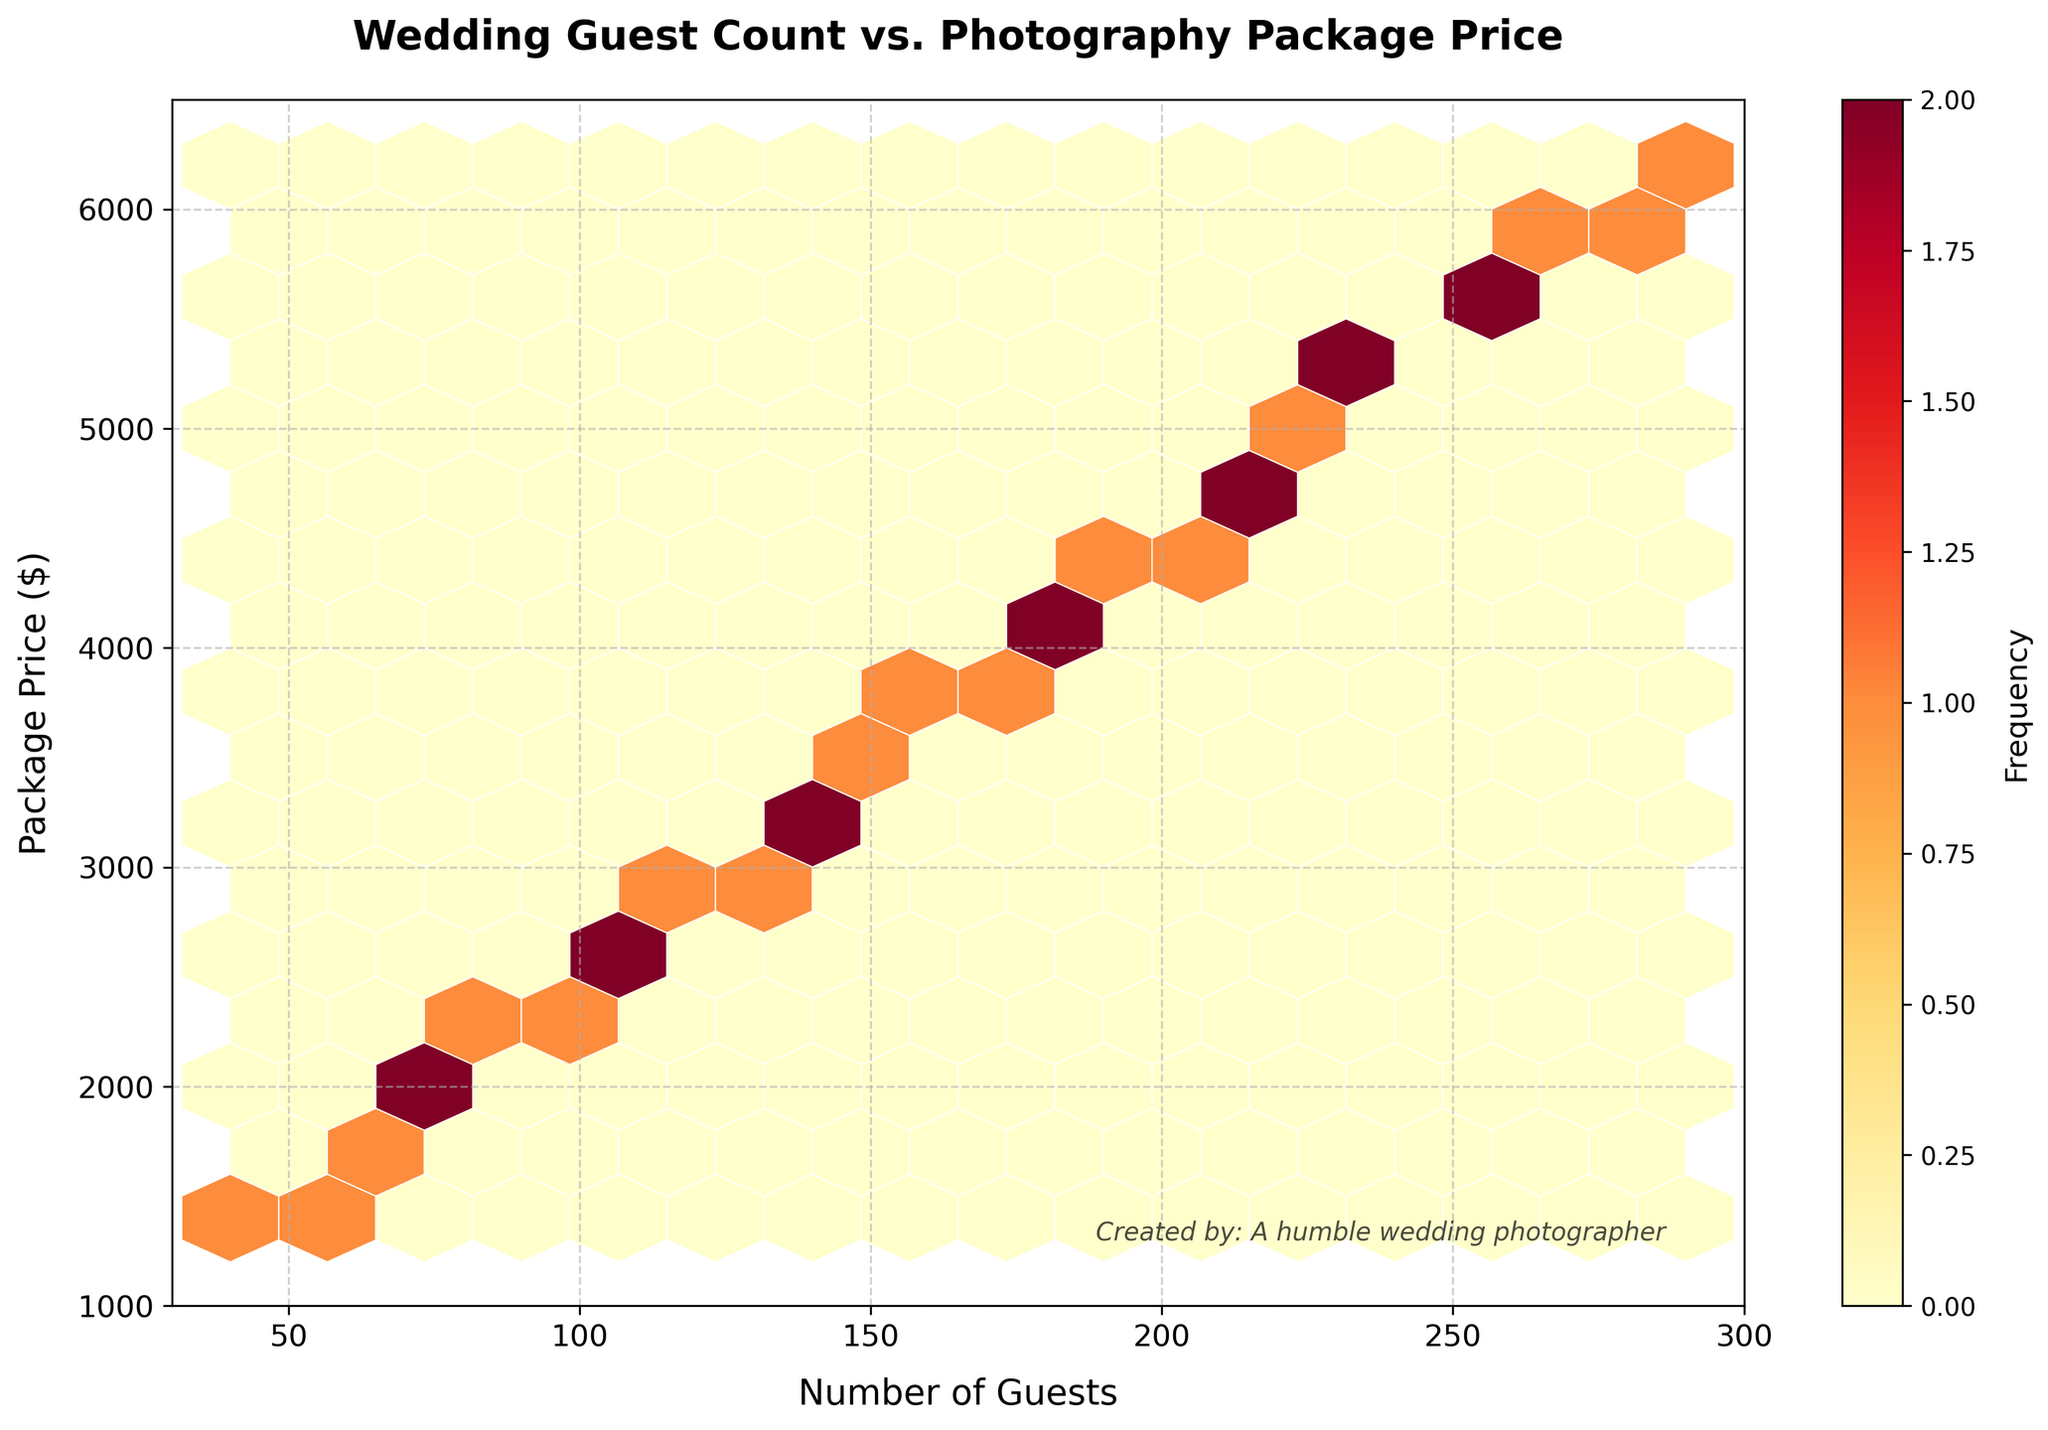What is the title of the plot? The title of the plot is displayed at the top center and reads "Wedding Guest Count vs. Photography Package Price".
Answer: Wedding Guest Count vs. Photography Package Price What are the labels of the x-axis and y-axis? The x-axis label is found below the horizontal axis and reads 'Number of Guests'. The y-axis label is found beside the vertical axis and reads 'Package Price ($)'.
Answer: Number of Guests and Package Price ($) What is the color of the hexagons representing the highest frequency? The hexagons with the highest frequency are shown in a darker shade of red.
Answer: Dark red What is the range of values on the x-axis? The x-axis is labeled 'Number of Guests' and ranges from 30 to 300, as shown below the axis.
Answer: 30 to 300 What is the color representing the lowest frequency in the hexbin plot? The color representing the lowest frequency in the hexbin plot is a light yellow, indicating fewer data points in those regions.
Answer: Light yellow What is the general trend shown in the hexbin plot? Observing the hexagons from left to right, there appears to be a general upward trend, indicating that as the number of guests increases, the photography package price tends to increase.
Answer: Upward trend Which price range has the most weddings when the guest count is about 200? When the guest count is approximately 200, the hexagons in the plot are darkest around the $4500 price range, indicating the highest frequency of weddings.
Answer: $4500 Are there any outliers in the data, and if so, where do they appear on the plot? Outliers are data points that fall outside the general trend. There are no distinct outliers visible as the data points form a continuous trend without any isolated hexagons far from others.
Answer: No outliers What is the frequency indicated by the darkest hexagons? The color bar shows that the darkest hexagons, representing the highest frequency, are at the top end of the color bar spectrum. The specific value isn't labeled but can be inferred to be the highest frequency in the data.
Answer: Highest frequency How does the frequency change as the guest count moves from 50 to 300? From 50 to 300 guests, the hexbin plot shows a transition from lighter colors (indicating lower frequency) to darker colors (indicating higher frequency), suggesting an increase in package selection frequency with larger guest counts.
Answer: Increase 